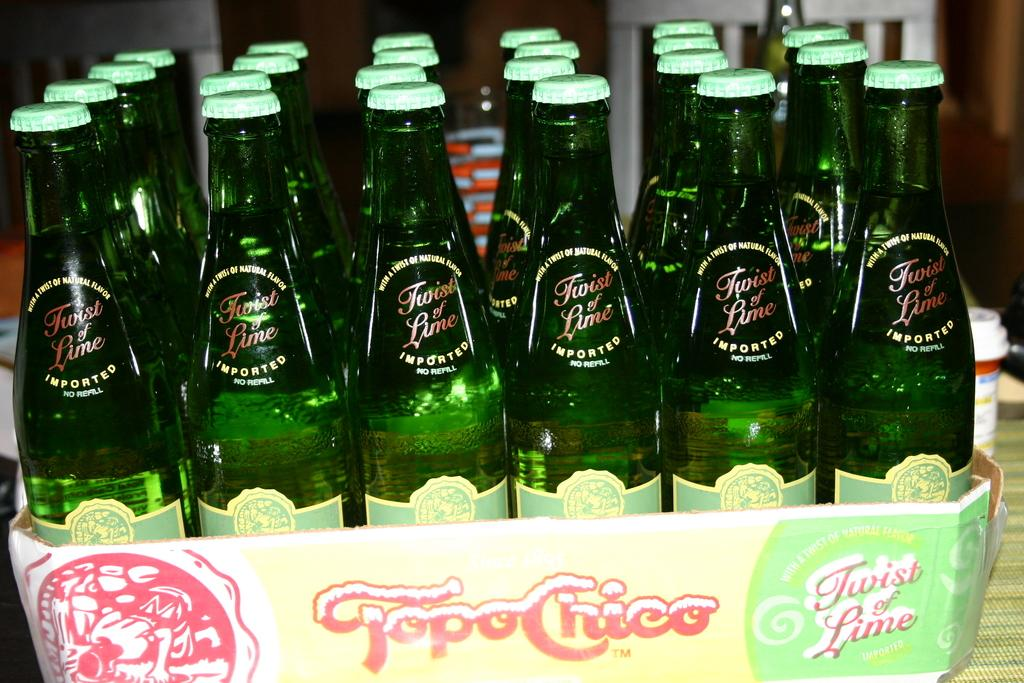What objects are on the table in the image? There are bottles on a table in the image. What type of scarf is being used to hold the bottles together in the image? There is no scarf present in the image, and the bottles are not being held together. 